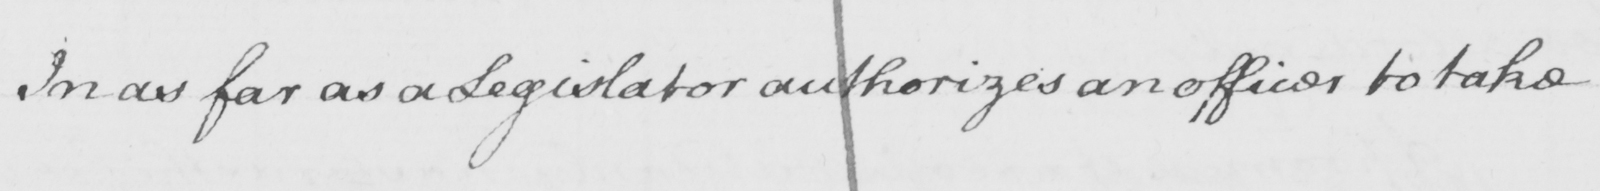What is written in this line of handwriting? In as far as a Legislator authorizes an officer to take 